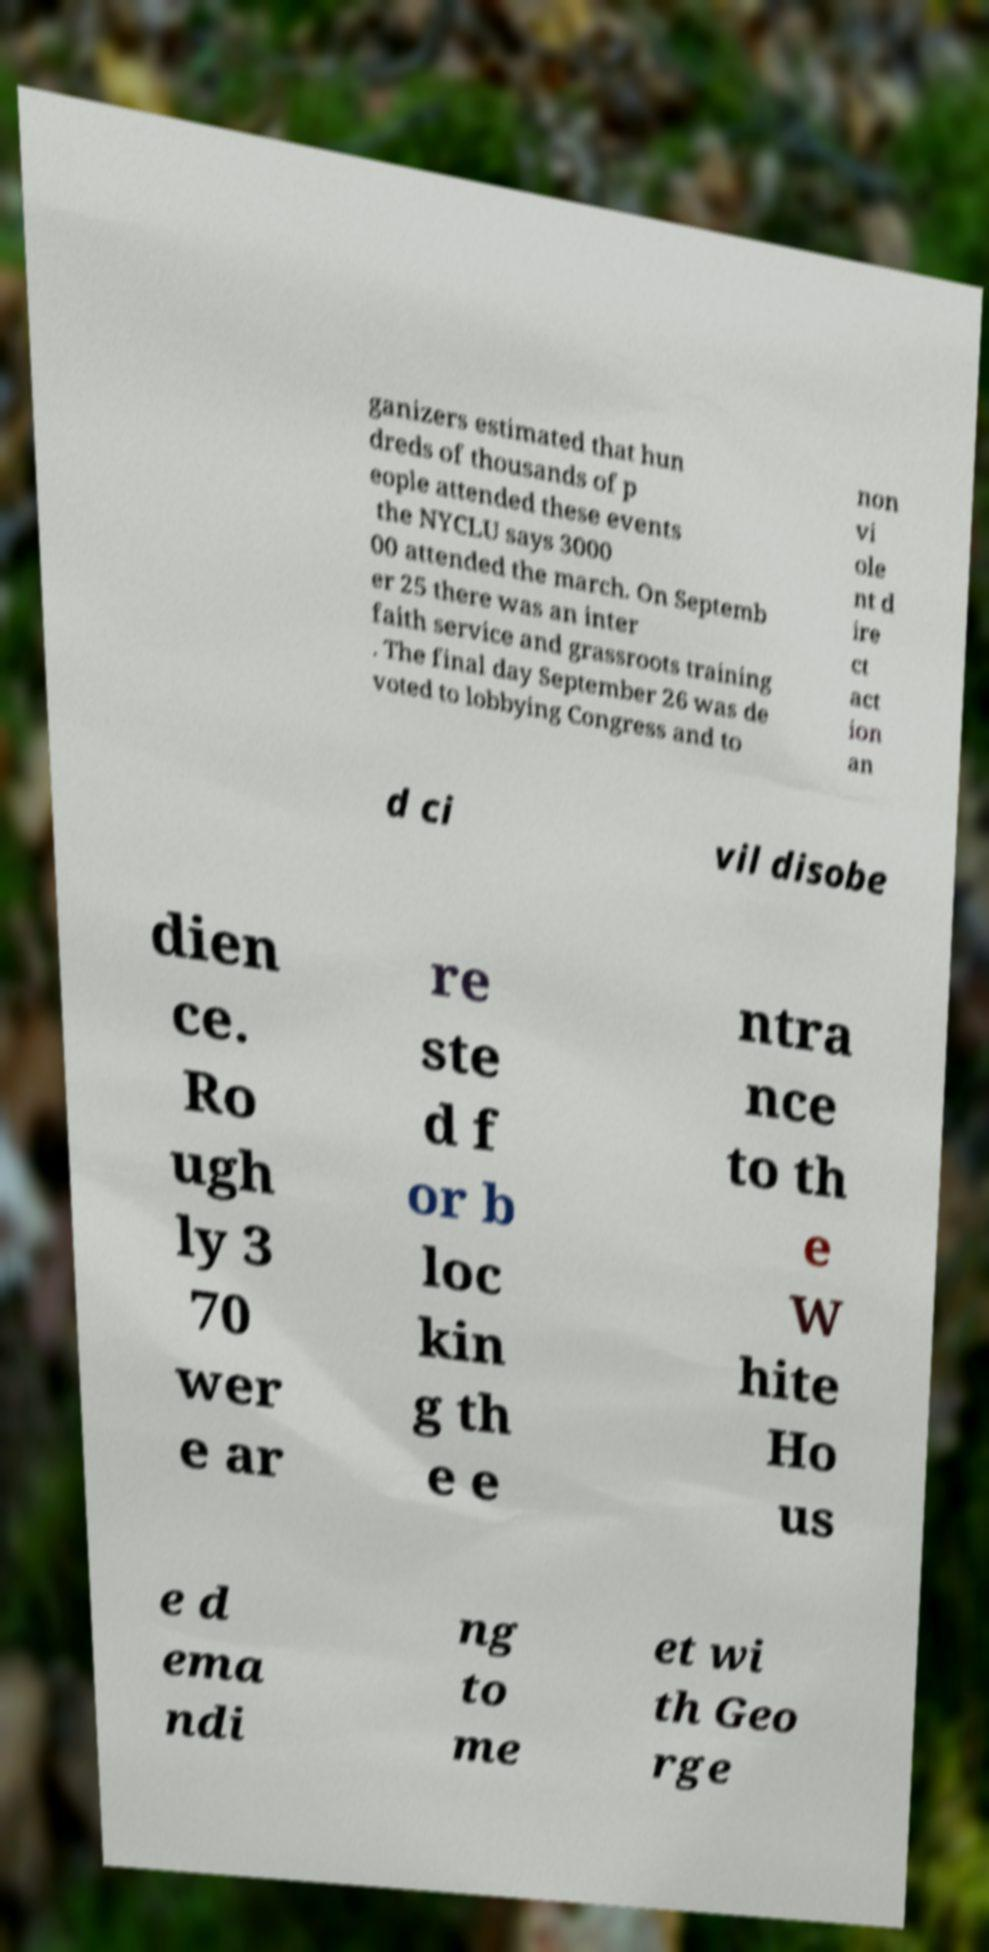Could you assist in decoding the text presented in this image and type it out clearly? ganizers estimated that hun dreds of thousands of p eople attended these events the NYCLU says 3000 00 attended the march. On Septemb er 25 there was an inter faith service and grassroots training . The final day September 26 was de voted to lobbying Congress and to non vi ole nt d ire ct act ion an d ci vil disobe dien ce. Ro ugh ly 3 70 wer e ar re ste d f or b loc kin g th e e ntra nce to th e W hite Ho us e d ema ndi ng to me et wi th Geo rge 